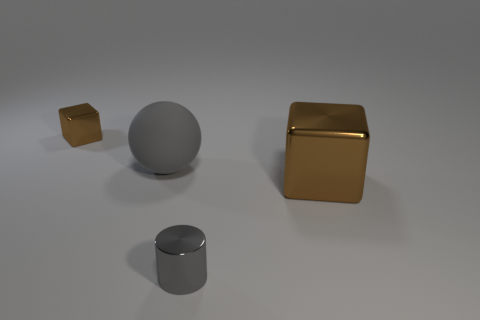Add 1 small brown metal things. How many objects exist? 5 Subtract all spheres. How many objects are left? 3 Subtract all tiny objects. Subtract all tiny blue shiny balls. How many objects are left? 2 Add 4 tiny brown metallic cubes. How many tiny brown metallic cubes are left? 5 Add 3 small gray cylinders. How many small gray cylinders exist? 4 Subtract 0 purple cylinders. How many objects are left? 4 